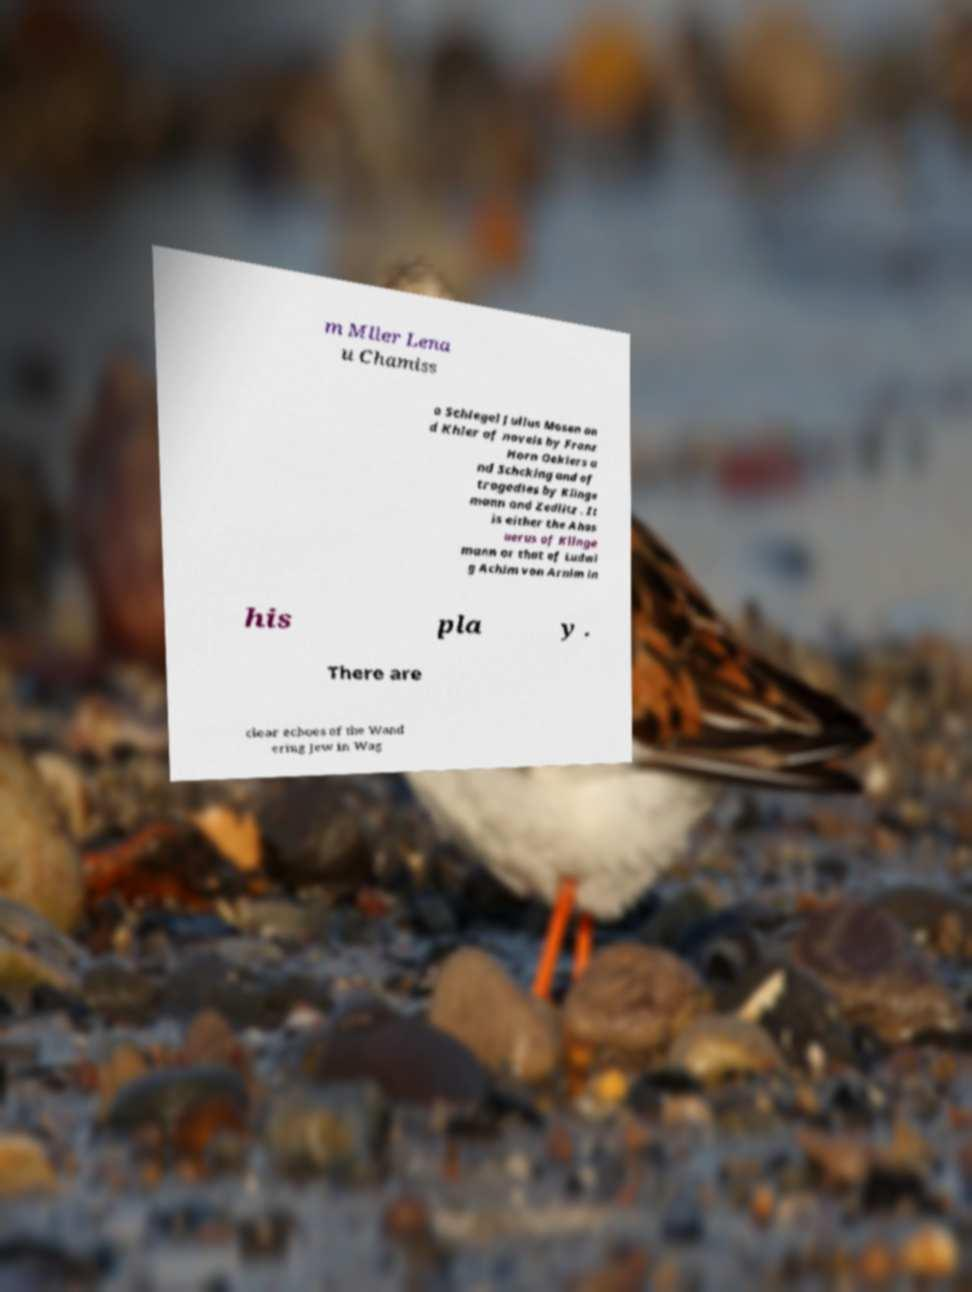I need the written content from this picture converted into text. Can you do that? m Mller Lena u Chamiss o Schlegel Julius Mosen an d Khler of novels by Franz Horn Oeklers a nd Schcking and of tragedies by Klinge mann and Zedlitz . It is either the Ahas uerus of Klinge mann or that of Ludwi g Achim von Arnim in his pla y . There are clear echoes of the Wand ering Jew in Wag 